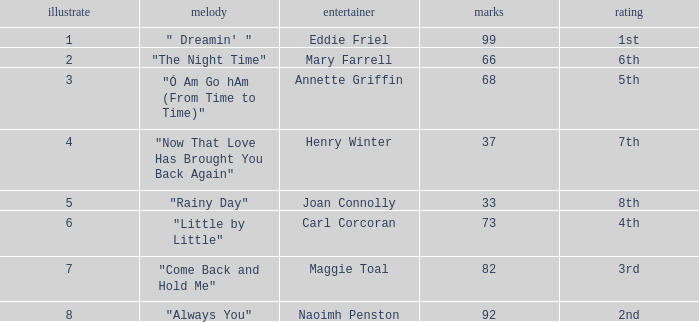Give me the full table as a dictionary. {'header': ['illustrate', 'melody', 'entertainer', 'marks', 'rating'], 'rows': [['1', '" Dreamin\' "', 'Eddie Friel', '99', '1st'], ['2', '"The Night Time"', 'Mary Farrell', '66', '6th'], ['3', '"Ó Am Go hAm (From Time to Time)"', 'Annette Griffin', '68', '5th'], ['4', '"Now That Love Has Brought You Back Again"', 'Henry Winter', '37', '7th'], ['5', '"Rainy Day"', 'Joan Connolly', '33', '8th'], ['6', '"Little by Little"', 'Carl Corcoran', '73', '4th'], ['7', '"Come Back and Hold Me"', 'Maggie Toal', '82', '3rd'], ['8', '"Always You"', 'Naoimh Penston', '92', '2nd']]} Which song has more than 66 points, a draw greater than 3, and is ranked 3rd? "Come Back and Hold Me". 